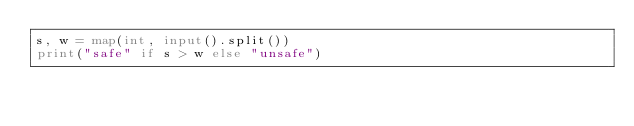<code> <loc_0><loc_0><loc_500><loc_500><_Python_>s, w = map(int, input().split())
print("safe" if s > w else "unsafe")</code> 